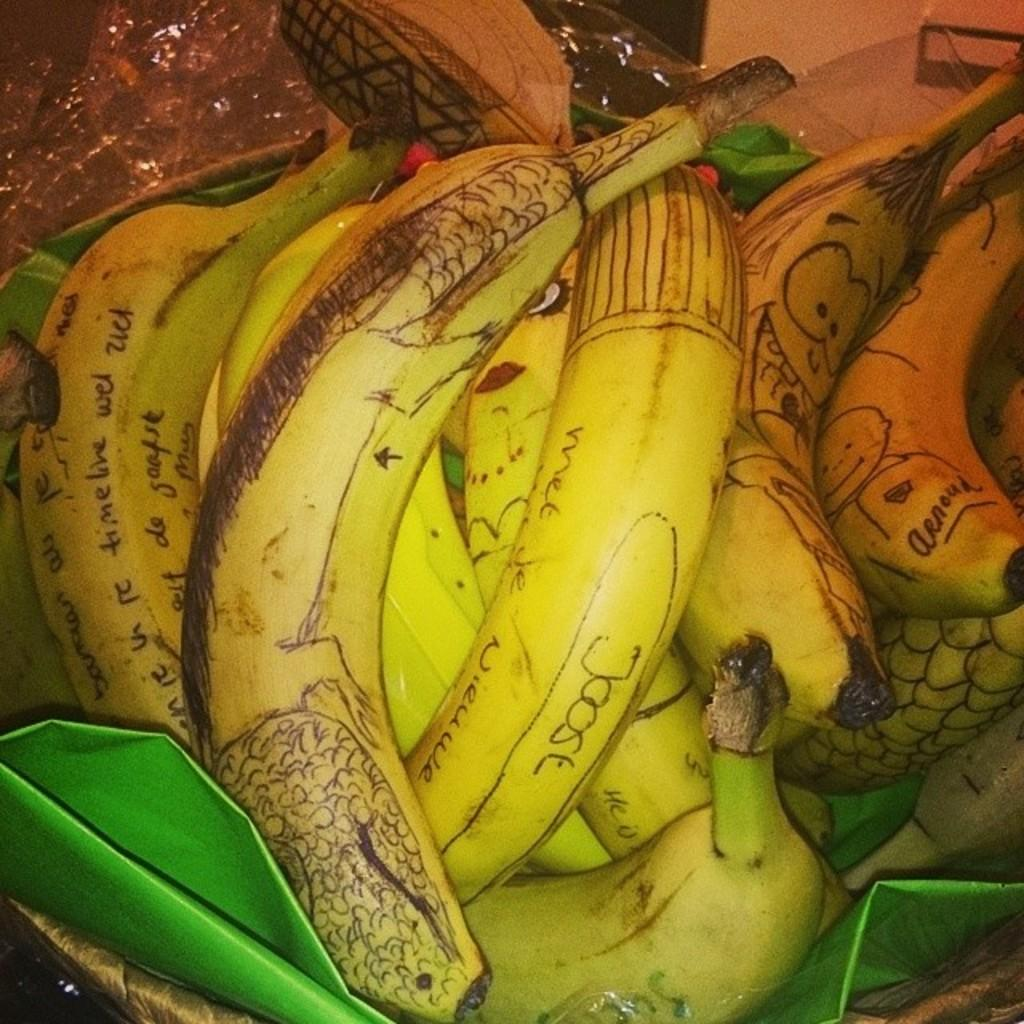What type of fruit is present in the image? There are bananas in the image. What color is the object in the basket? The object in the basket is green. How are the bananas decorated? The bananas have drawings and words on them. What is covering the top of the image? There is a plastic cover at the top of the image. How many snakes are slithering around the bananas in the image? There are no snakes present in the image; it only contains bananas, a green object, and a plastic cover. 